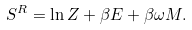Convert formula to latex. <formula><loc_0><loc_0><loc_500><loc_500>S ^ { R } = \ln Z + \beta E + \beta \omega M .</formula> 